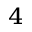Convert formula to latex. <formula><loc_0><loc_0><loc_500><loc_500>^ { 4 }</formula> 